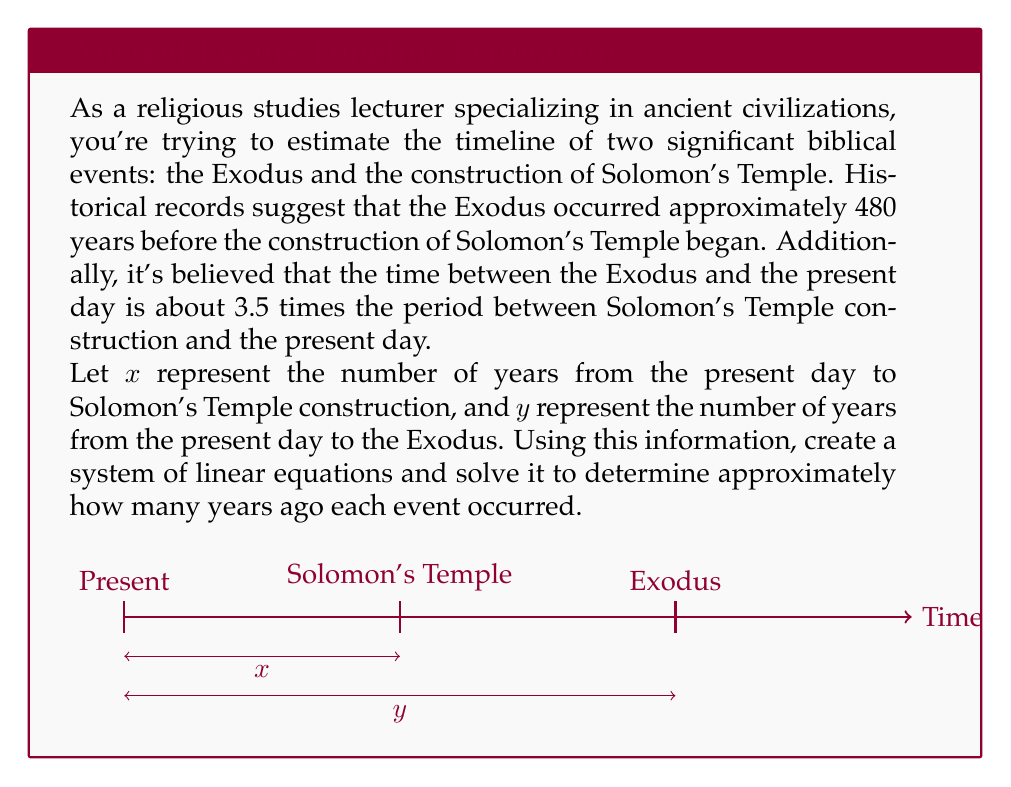Teach me how to tackle this problem. Let's approach this problem step-by-step:

1) First, let's define our variables:
   $x$ = years from present day to Solomon's Temple construction
   $y$ = years from present day to the Exodus

2) Now, let's create our system of equations based on the given information:

   Equation 1: The Exodus occurred 480 years before Solomon's Temple construction
   $$y = x + 480$$

   Equation 2: The time between the Exodus and present day is 3.5 times the period between Solomon's Temple construction and present day
   $$y = 3.5x$$

3) We now have a system of two linear equations:
   $$\begin{cases}
   y = x + 480 \\
   y = 3.5x
   \end{cases}$$

4) To solve this system, let's equate the two expressions for $y$:
   $$x + 480 = 3.5x$$

5) Subtract $x$ from both sides:
   $$480 = 2.5x$$

6) Divide both sides by 2.5:
   $$x = 480 \div 2.5 = 192$$

7) Now that we know $x$, we can substitute it into either of the original equations to find $y$. Let's use the second equation:
   $$y = 3.5x = 3.5 \times 192 = 672$$

8) Therefore:
   Solomon's Temple construction occurred approximately 192 years ago
   The Exodus occurred approximately 672 years ago

Note: These figures are relative to the "present day" in the context of the problem, not our actual present day.
Answer: Solomon's Temple: 192 years ago; Exodus: 672 years ago 